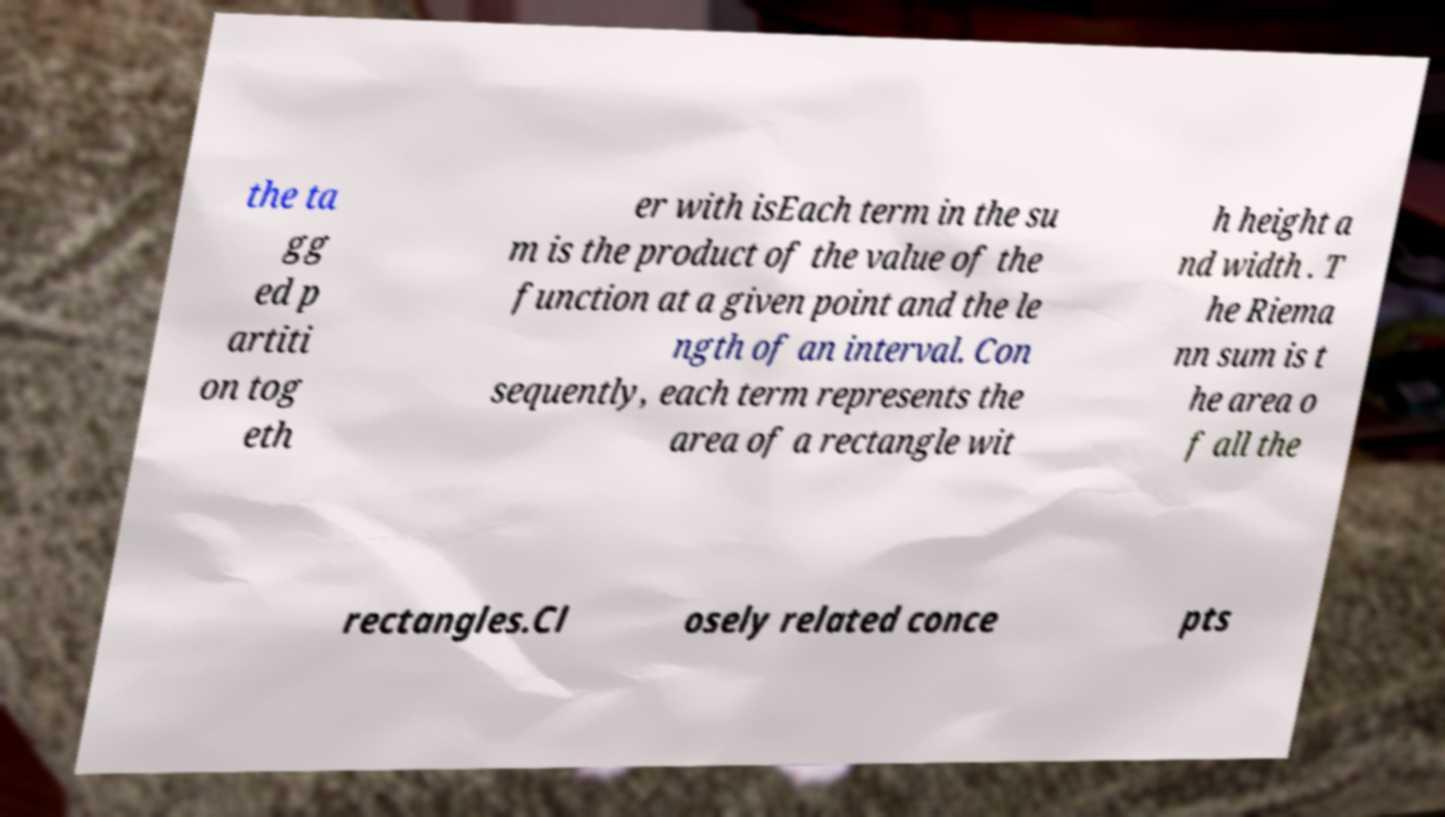For documentation purposes, I need the text within this image transcribed. Could you provide that? the ta gg ed p artiti on tog eth er with isEach term in the su m is the product of the value of the function at a given point and the le ngth of an interval. Con sequently, each term represents the area of a rectangle wit h height a nd width . T he Riema nn sum is t he area o f all the rectangles.Cl osely related conce pts 